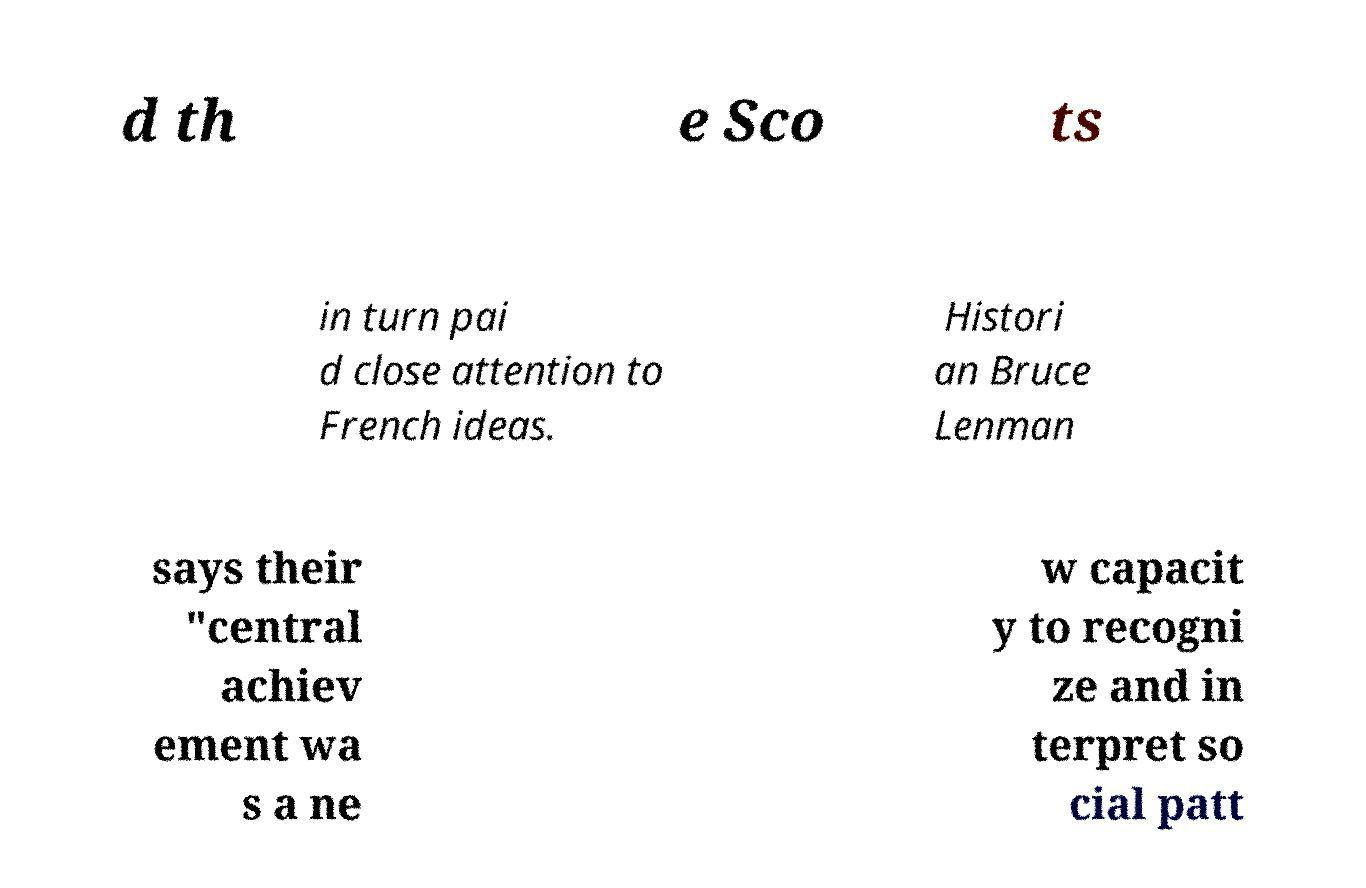There's text embedded in this image that I need extracted. Can you transcribe it verbatim? d th e Sco ts in turn pai d close attention to French ideas. Histori an Bruce Lenman says their "central achiev ement wa s a ne w capacit y to recogni ze and in terpret so cial patt 